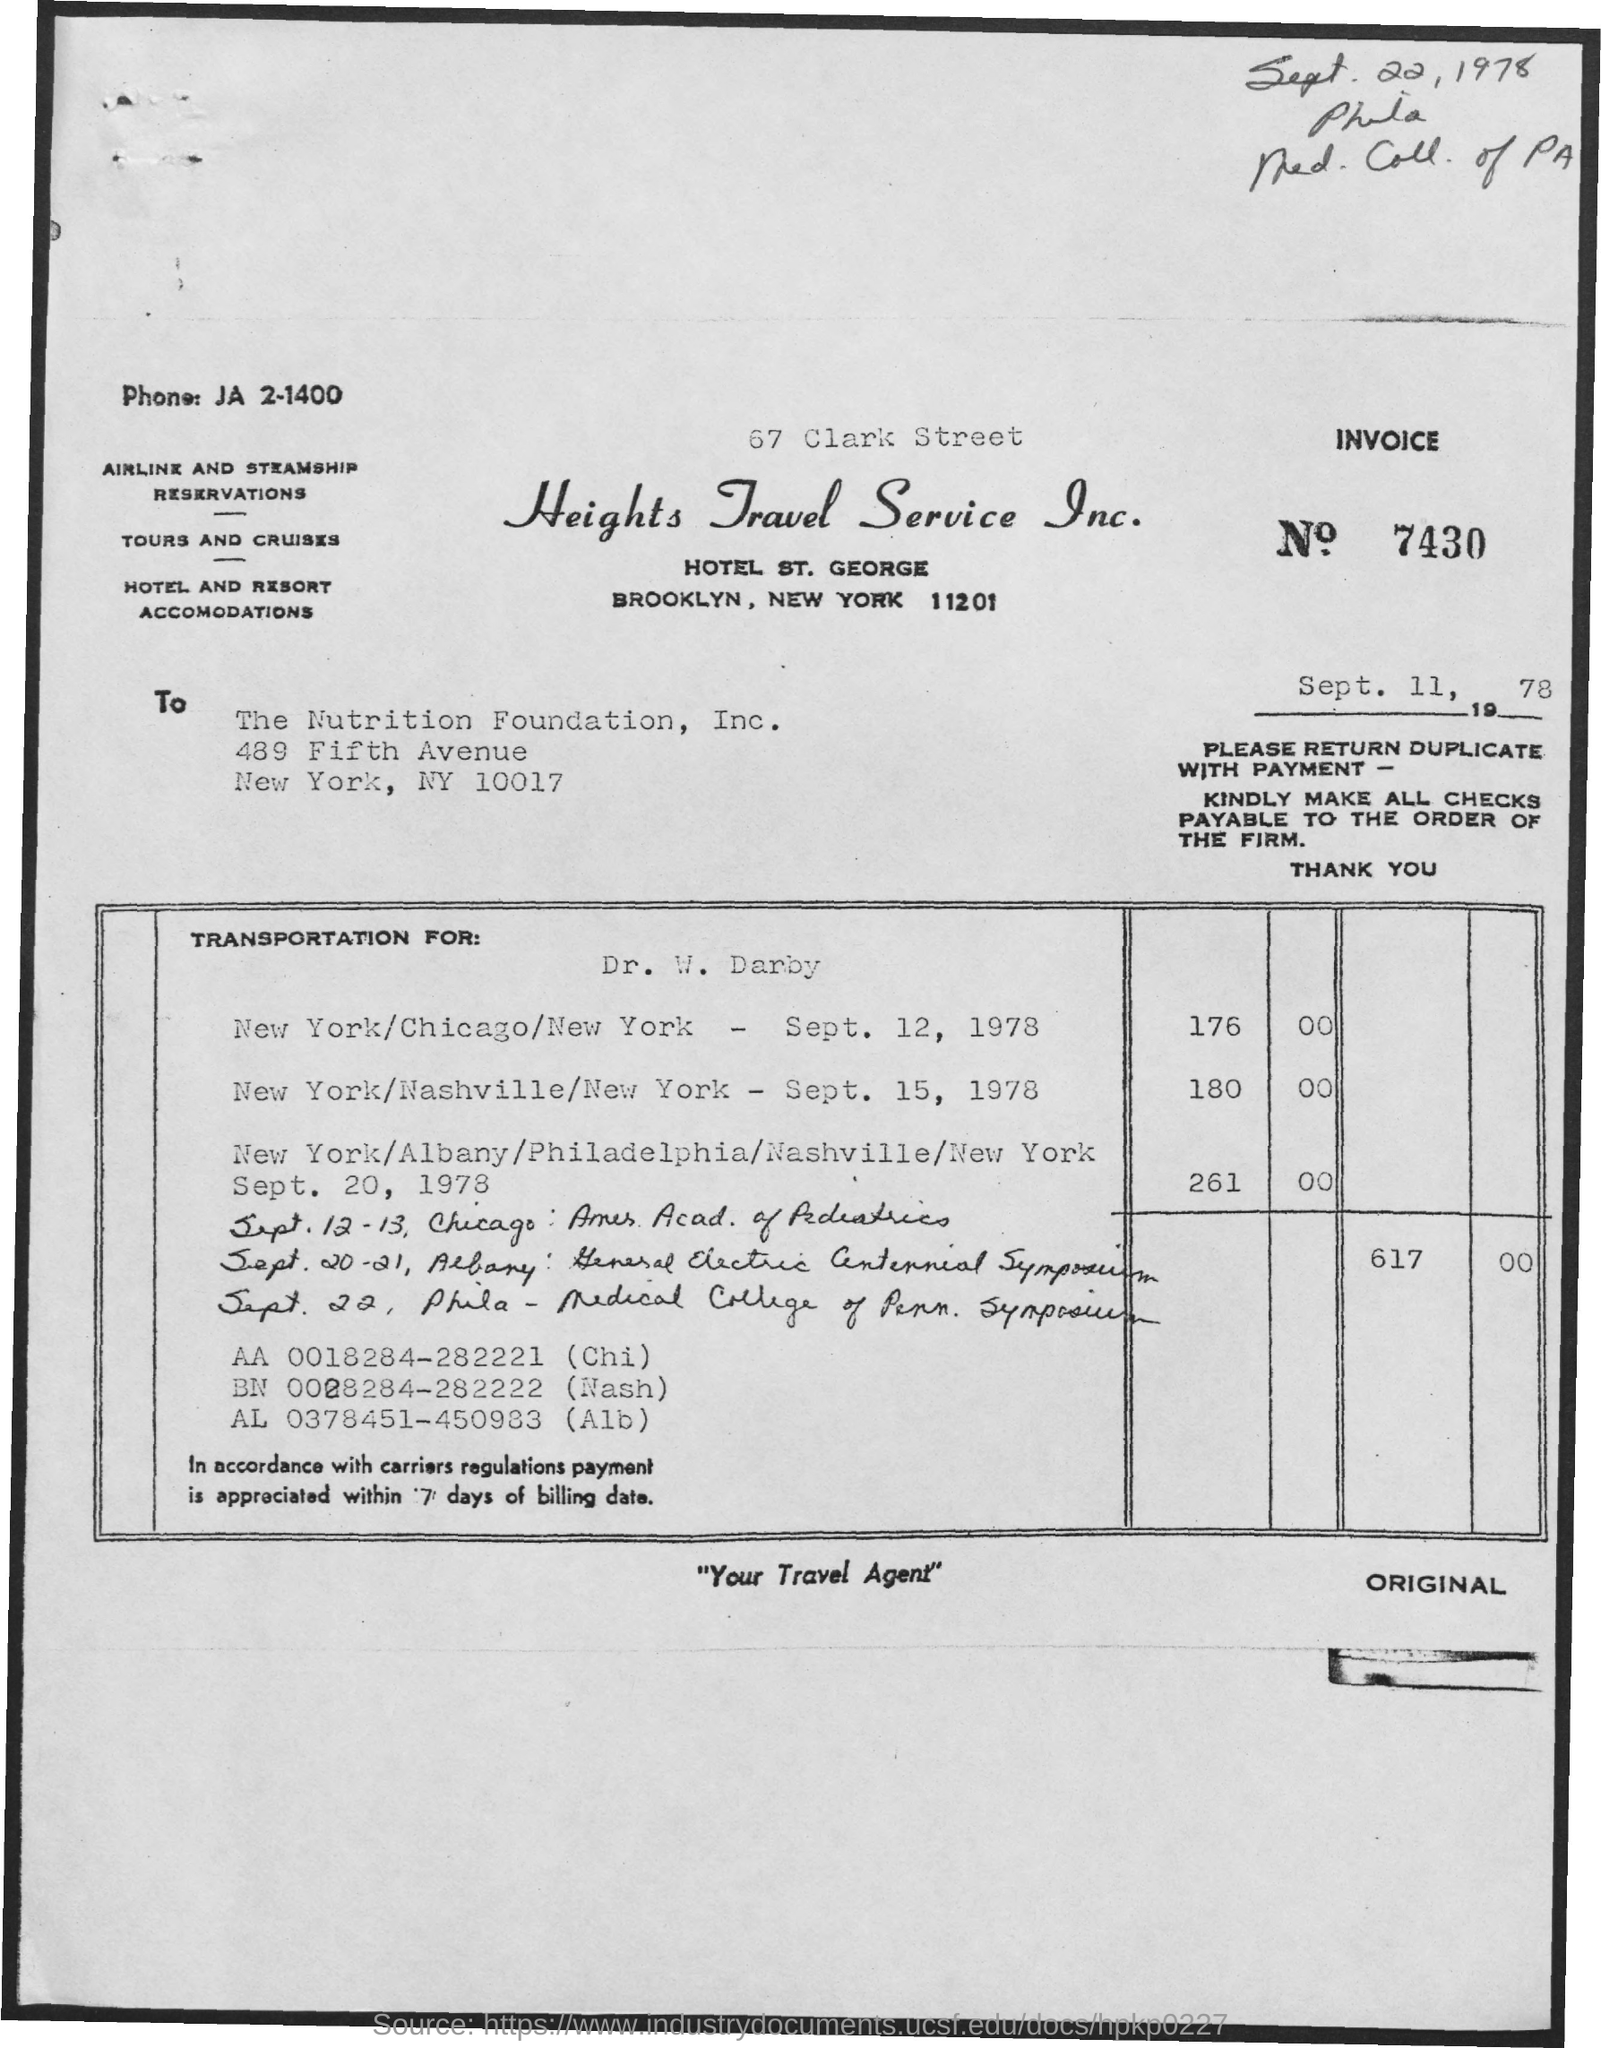What is the Invoice Number?
Ensure brevity in your answer.  7430. What is the date below the invoice number?
Provide a short and direct response. Sept. 11, 1978. What is the date at the top right of the document?
Offer a terse response. Sept. 22, 1978. 